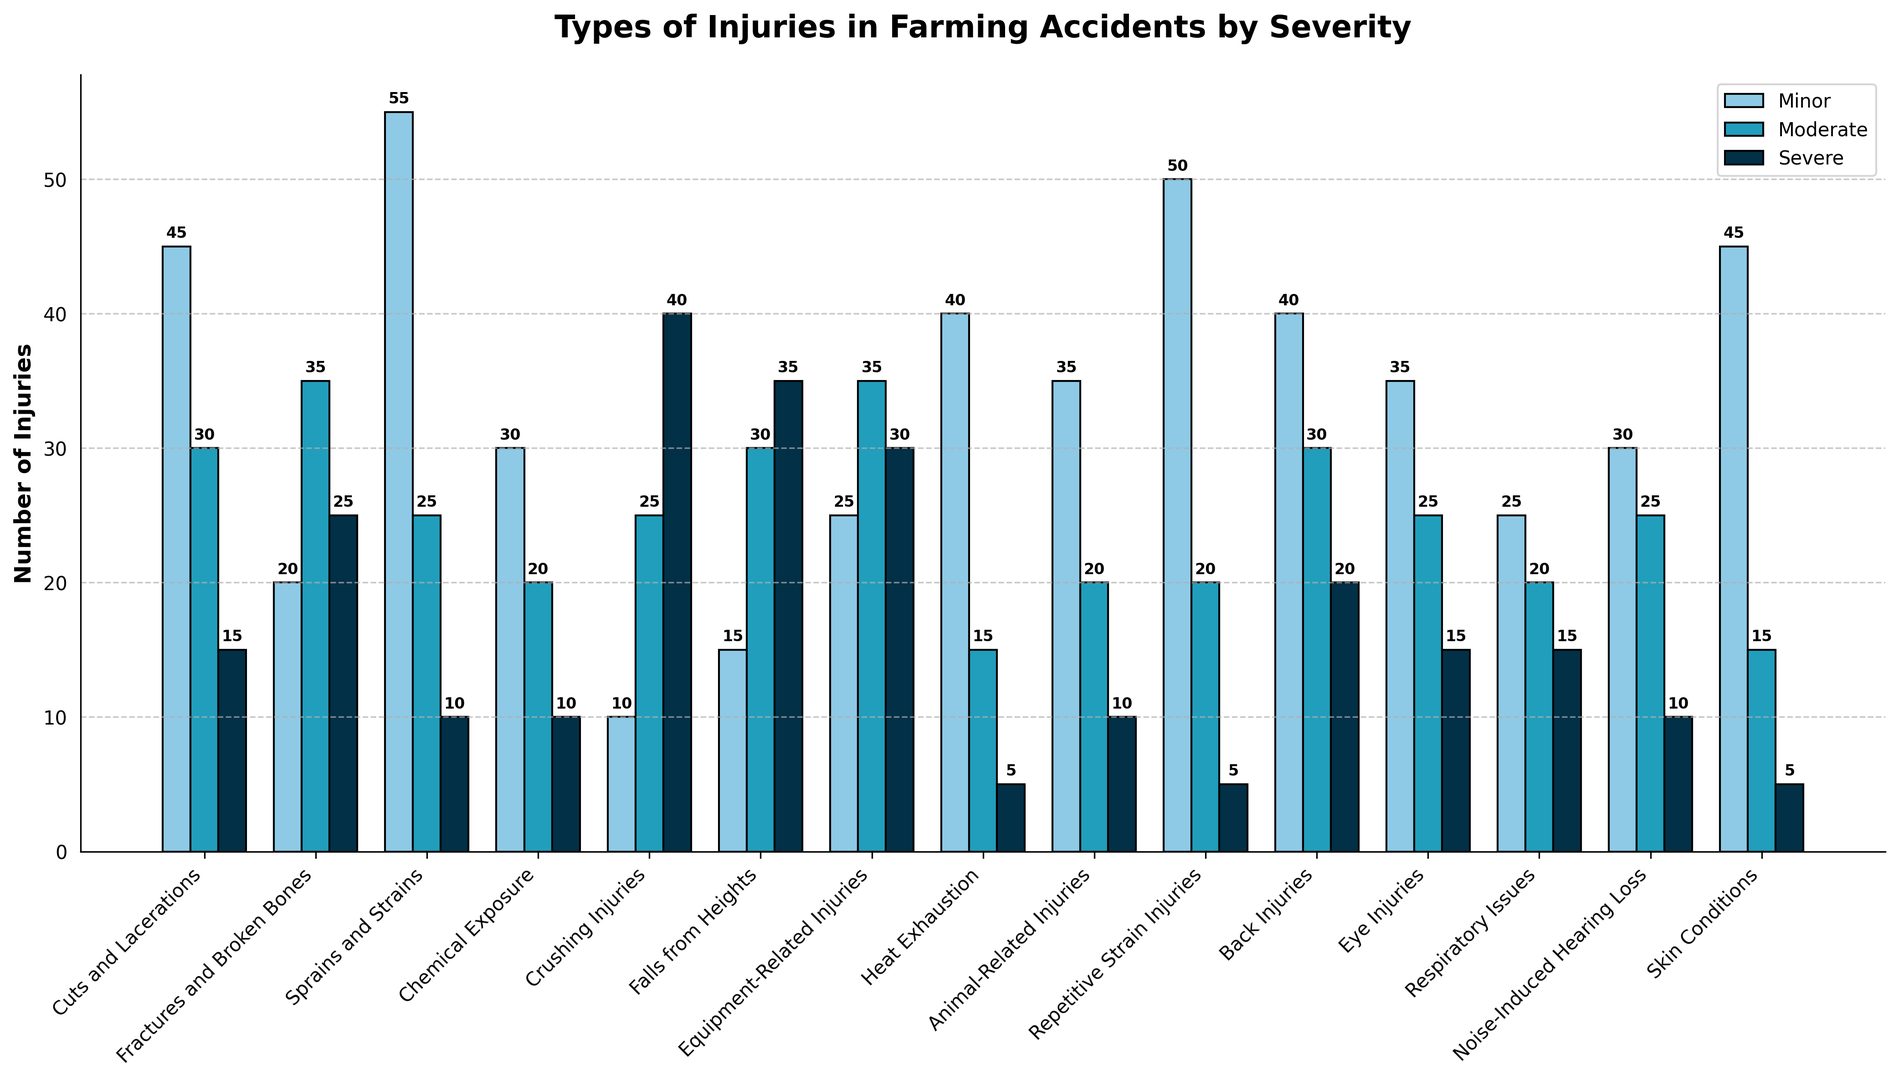Which injury type has the highest number of severe injuries? Look at the bars for severe injuries (dark blue) across all injury types. The tallest bar in this category corresponds to "Crushing Injuries".
Answer: Crushing Injuries What is the sum of moderate and severe injuries for Fractures and Broken Bones? Add the moderate injuries (35) and severe injuries (25) for Fractures and Broken Bones. 35 + 25 = 60.
Answer: 60 Are minor or severe injuries more common for Eye Injuries? Compare the heights of the minor (light blue) and severe (dark blue) bars for Eye Injuries. The minor bar is taller than the severe bar.
Answer: Minor Which injury type has an equal number of moderate and severe injuries? Look for pairs of moderate (medium blue) and severe (dark blue) bars that are of the same height. "Chemical Exposure" both have 10 injuries in each category.
Answer: Chemical Exposure What is the ratio of minor to severe injuries for Sprains and Strains? Divide the number of minor injuries (55) by the number of severe injuries (10) for Sprains and Strains. 55 / 10 = 5.5.
Answer: 5.5 How many total injuries are there for Falls from Heights? Add the minor (15), moderate (30), and severe (35) injuries for Falls from Heights. 15 + 30 + 35 = 80.
Answer: 80 Which two injury types have the most severe injuries combined? Identify the top two injury types by the height of their severe bars (dark blue), which are "Crushing Injuries" (40) and "Falls from Heights" (35). 40 + 35 = 75.
Answer: Crushing Injuries and Falls from Heights How does the number of moderate injuries for Equipment-Related Injuries compare to Chemical Exposure? Compare the heights of the moderate bars (medium blue) for both categories. Equipment-Related Injuries have a moderate injury count of 35, while Chemical Exposure has 20. 35 > 20.
Answer: Equipment-Related Injuries has more What is the average number of severe injuries across all injury types? (Hint: Average = Total severe injuries / Number of injury types) Sum the severe injuries for all types (15 + 25 + 10 + 10 + 40 + 35 + 30 + 5 + 10 + 5 + 20 + 15 + 15 + 10 + 5 = 260). There are 15 injury types. 260 / 15 ≈ 17.33.
Answer: Approximately 17.33 Which injury type has the highest number of minor injuries, and what is the count? The tallest light blue bar indicates the highest number of minor injuries, which corresponds to "Sprains and Strains" with 55 injuries.
Answer: Sprains and Strains, 55 